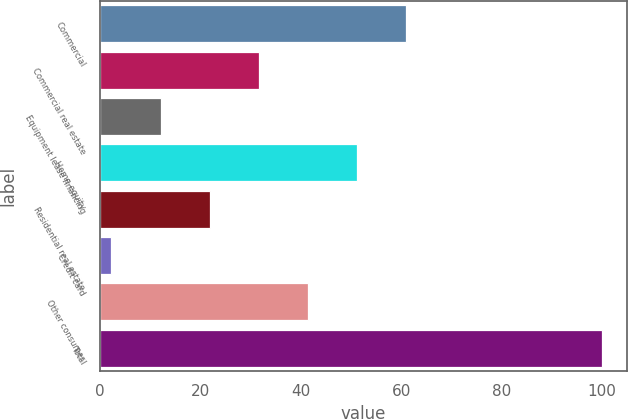<chart> <loc_0><loc_0><loc_500><loc_500><bar_chart><fcel>Commercial<fcel>Commercial real estate<fcel>Equipment lease financing<fcel>Home equity<fcel>Residential real estate<fcel>Credit card<fcel>Other consumer<fcel>Total<nl><fcel>60.92<fcel>31.61<fcel>12.07<fcel>51.15<fcel>21.84<fcel>2.3<fcel>41.38<fcel>100<nl></chart> 